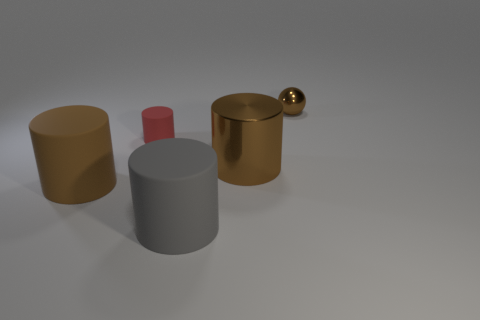How many other things are made of the same material as the tiny brown object?
Provide a succinct answer. 1. What size is the red object that is the same shape as the brown rubber thing?
Give a very brief answer. Small. There is a large brown thing behind the rubber thing that is left of the tiny object that is to the left of the big brown metallic thing; what is its material?
Your answer should be very brief. Metal. Are there any small brown metallic objects?
Keep it short and to the point. Yes. Do the small metal object and the large cylinder left of the big gray matte cylinder have the same color?
Your answer should be compact. Yes. What color is the tiny matte thing?
Give a very brief answer. Red. Is there any other thing that is the same shape as the small red thing?
Give a very brief answer. Yes. There is a tiny rubber object that is the same shape as the big metal object; what is its color?
Give a very brief answer. Red. Is the small brown shiny thing the same shape as the red object?
Provide a succinct answer. No. What number of spheres are tiny rubber things or big shiny objects?
Your answer should be very brief. 0. 